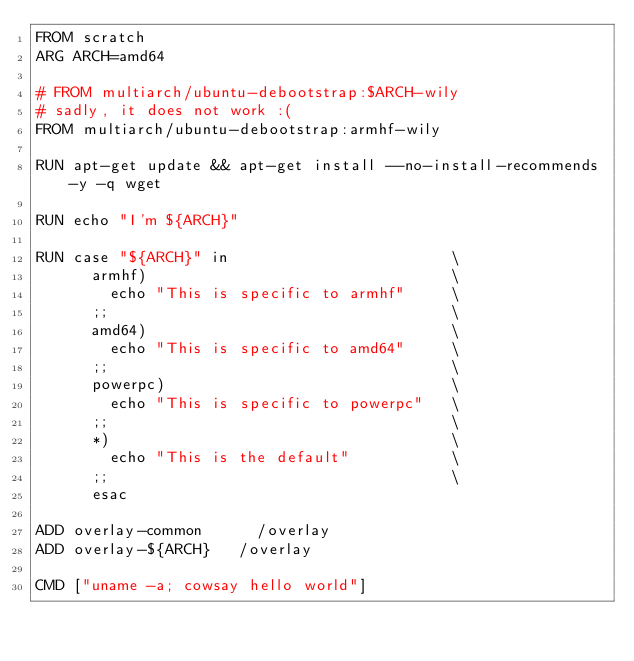Convert code to text. <code><loc_0><loc_0><loc_500><loc_500><_Dockerfile_>FROM scratch
ARG ARCH=amd64

# FROM multiarch/ubuntu-debootstrap:$ARCH-wily
# sadly, it does not work :(
FROM multiarch/ubuntu-debootstrap:armhf-wily

RUN apt-get update && apt-get install --no-install-recommends -y -q wget

RUN echo "I'm ${ARCH}"

RUN case "${ARCH}" in                        \
      armhf)                                 \
        echo "This is specific to armhf"     \
      ;;                                     \
      amd64)                                 \
        echo "This is specific to amd64"     \
      ;;                                     \
      powerpc)                               \
        echo "This is specific to powerpc"   \
      ;;                                     \
      *)                                     \
        echo "This is the default"           \
      ;;                                     \
      esac
    
ADD overlay-common      /overlay
ADD overlay-${ARCH}   /overlay

CMD ["uname -a; cowsay hello world"]
</code> 